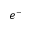<formula> <loc_0><loc_0><loc_500><loc_500>e ^ { - }</formula> 